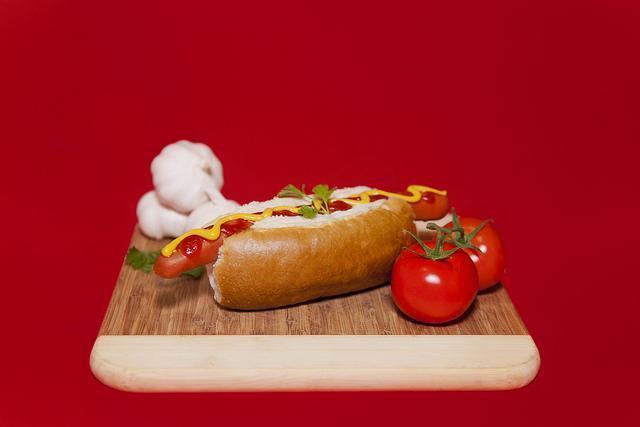How many elephants are standing up in the water?
Give a very brief answer. 0. 